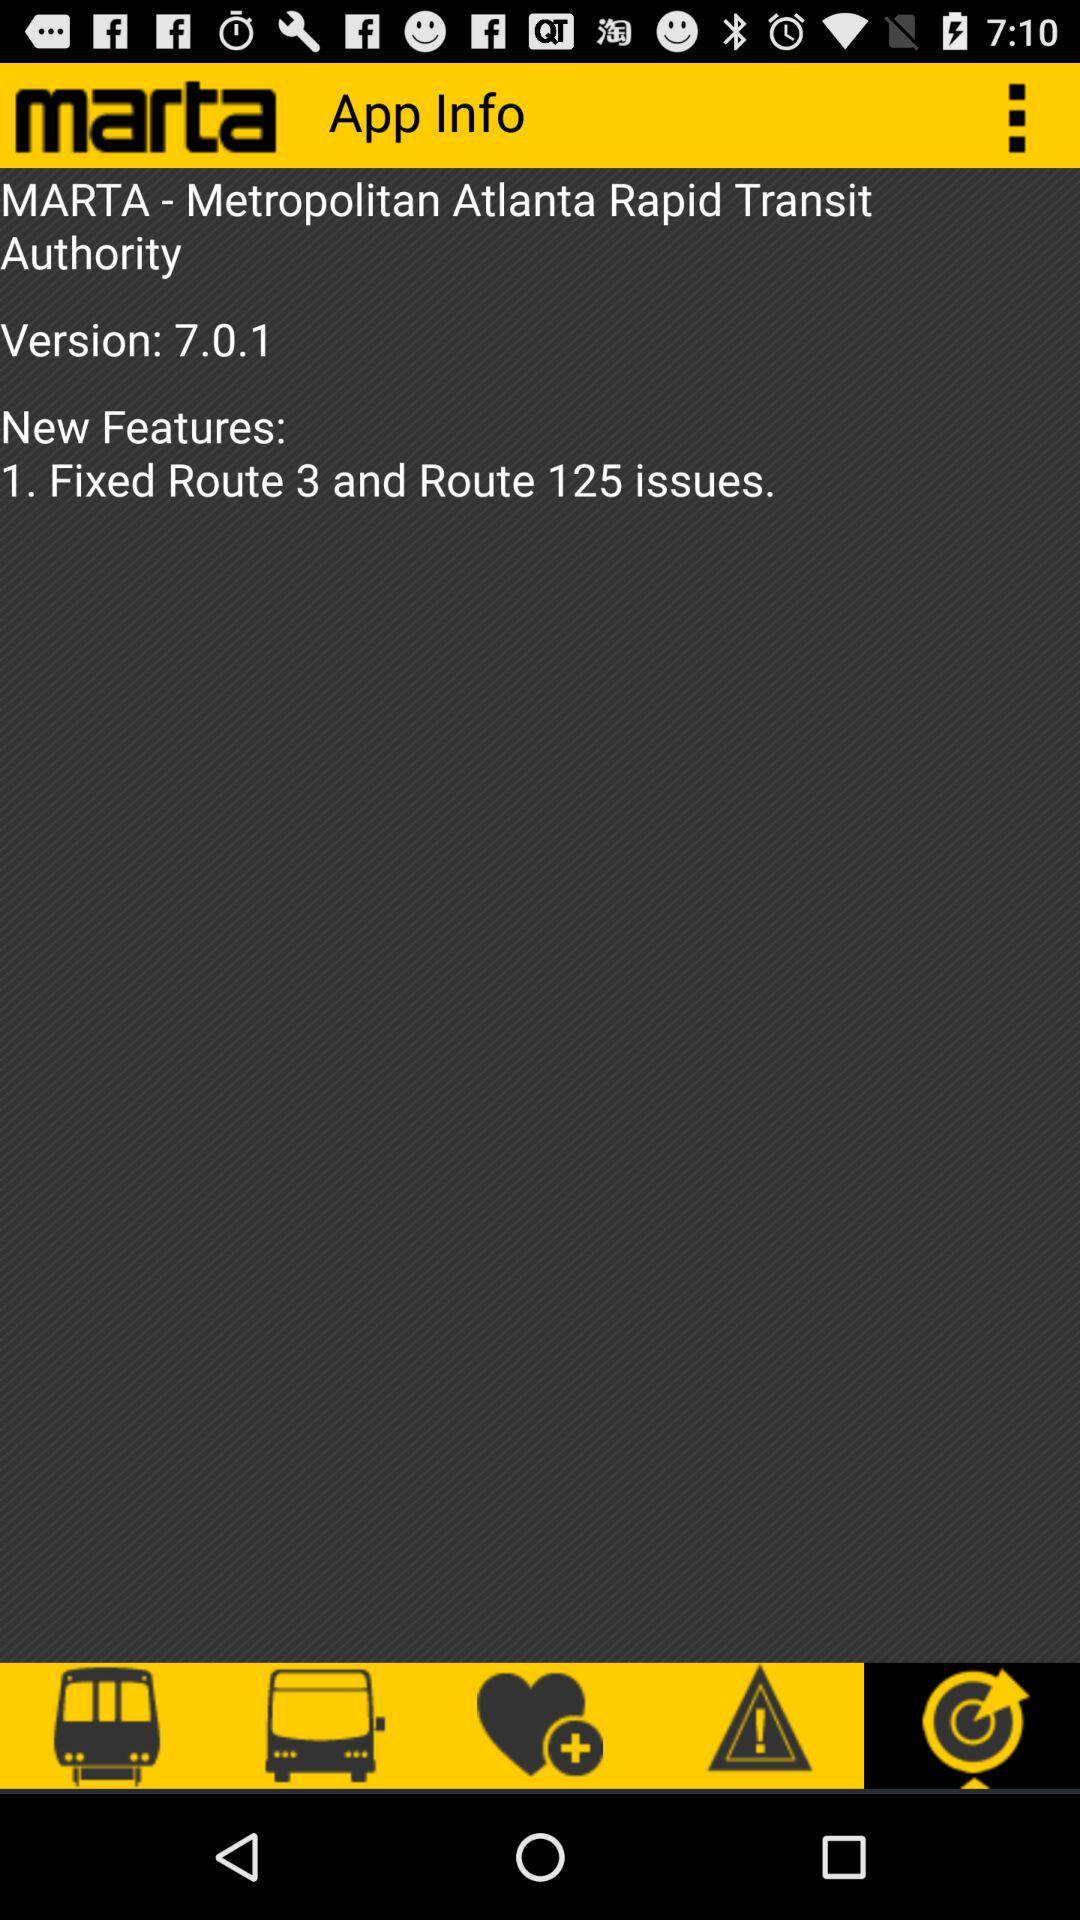What is the version of "marta"? The version is 7.0.1. 